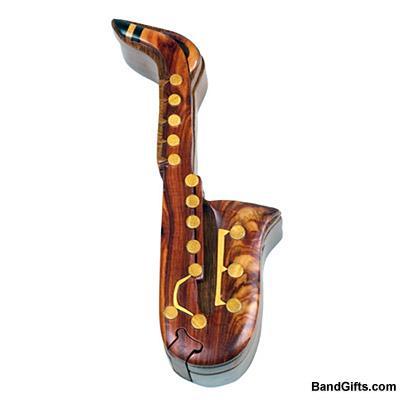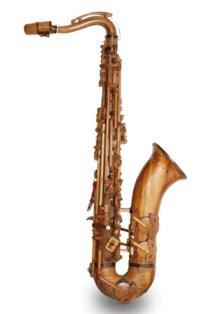The first image is the image on the left, the second image is the image on the right. Evaluate the accuracy of this statement regarding the images: "The left image shows one instrument displayed on a wooden stand.". Is it true? Answer yes or no. No. The first image is the image on the left, the second image is the image on the right. Considering the images on both sides, is "The saxophone in the image on the left is on a stand." valid? Answer yes or no. No. 